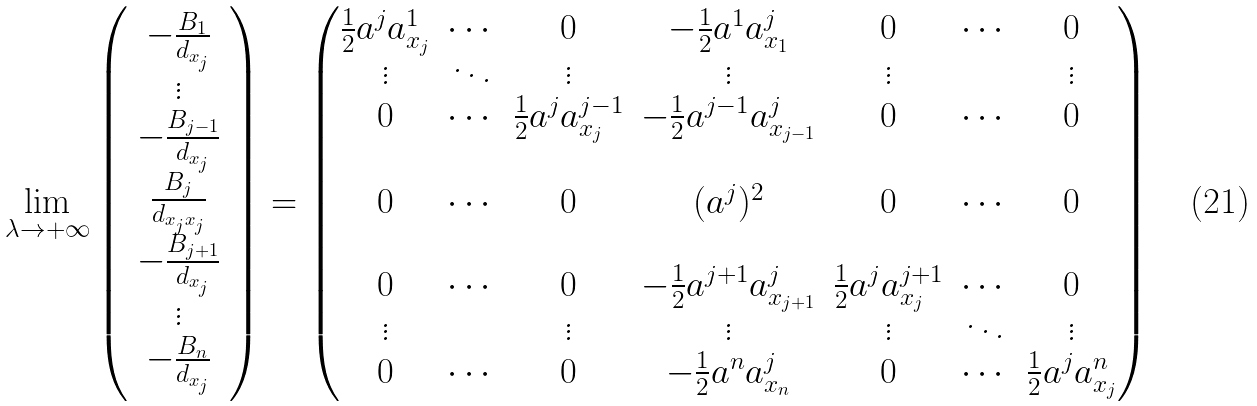<formula> <loc_0><loc_0><loc_500><loc_500>\lim _ { \lambda \to + \infty } \left ( \begin{array} { c c } - \frac { B _ { 1 } } { d _ { x _ { j } } } \\ \vdots \\ - \frac { B _ { j - 1 } } { d _ { x _ { j } } } \\ \frac { B _ { j } } { d _ { x _ { j } x _ { j } } } \\ - \frac { B _ { j + 1 } } { d _ { x _ { j } } } \\ \vdots \\ - \frac { B _ { n } } { d _ { x _ { j } } } \end{array} \right ) = \begin{pmatrix} \frac { 1 } { 2 } a ^ { j } a ^ { 1 } _ { x _ { j } } & \cdots & 0 & - \frac { 1 } { 2 } a ^ { 1 } a ^ { j } _ { x _ { 1 } } & 0 & \cdots & 0 \\ \vdots & \ddots & \vdots & \vdots & \vdots & & \vdots \\ 0 & \cdots & \frac { 1 } { 2 } a ^ { j } a ^ { j - 1 } _ { x _ { j } } & - \frac { 1 } { 2 } a ^ { j - 1 } a ^ { j } _ { x _ { j - 1 } } & 0 & \cdots & 0 \\ \\ 0 & \cdots & 0 & ( a ^ { j } ) ^ { 2 } & 0 & \cdots & 0 \\ \\ 0 & \cdots & 0 & - \frac { 1 } { 2 } a ^ { j + 1 } a ^ { j } _ { x _ { j + 1 } } & \frac { 1 } { 2 } a ^ { j } a ^ { j + 1 } _ { x _ { j } } & \cdots & 0 \\ \vdots & & \vdots & \vdots & \vdots & \ddots & \vdots \\ 0 & \cdots & 0 & - \frac { 1 } { 2 } a ^ { n } a ^ { j } _ { x _ { n } } & 0 & \cdots & \frac { 1 } { 2 } a ^ { j } a ^ { n } _ { x _ { j } } \end{pmatrix}</formula> 